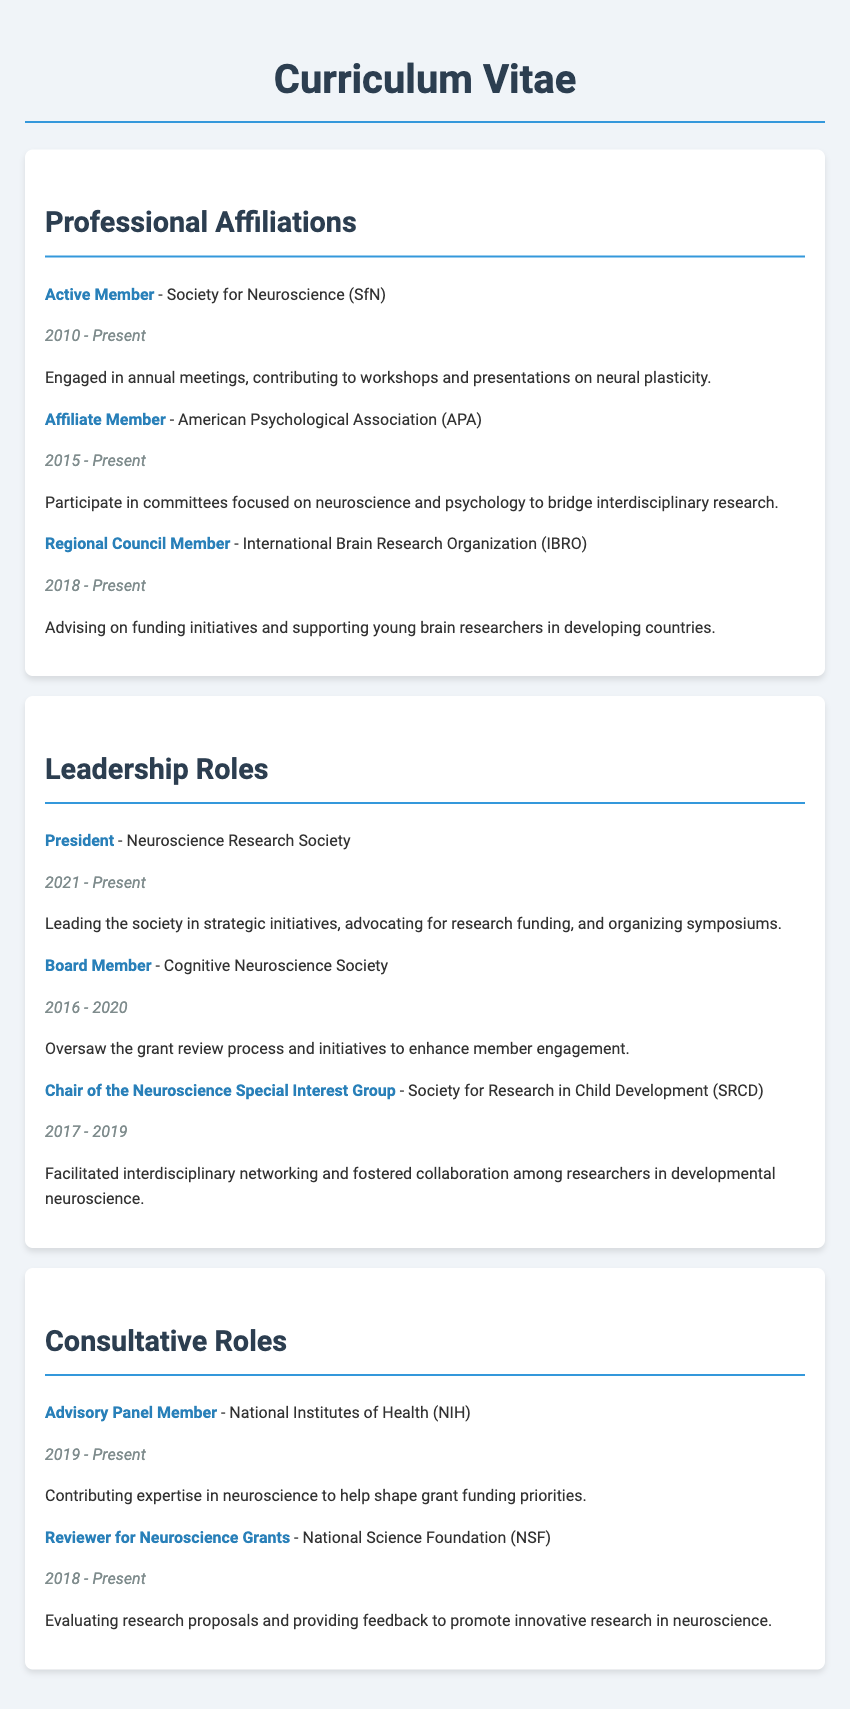what is the title of the curriculum vitae? The title appears at the top of the document as "Curriculum Vitae".
Answer: Curriculum Vitae how many years has the person been an Active Member of the Society for Neuroscience? The document states the membership period is from 2010 to Present, which is approximately 13 years.
Answer: 13 years who is currently the President of the Neuroscience Research Society? The document lists the title and organization along with the person's role, indicating they are the current President.
Answer: President which organization has the individual served as a Board Member? The document specifies the role of Board Member for the Cognitive Neuroscience Society.
Answer: Cognitive Neuroscience Society in which year did the individual start their role as Chair of the Neuroscience Special Interest Group? The document shows the person's term started in 2017.
Answer: 2017 what is the primary responsibility of the Regional Council Member at IBRO? The description states they are advising on funding initiatives and supporting young brain researchers.
Answer: Advising on funding initiatives how long did the individual serve as a Board Member from 2016 to 2020? The service duration is calculated from the years given in the document.
Answer: 4 years which professional society is focused on interdisciplinary research between neuroscience and psychology? The document indicates the individual is an Affiliate Member of the American Psychological Association.
Answer: American Psychological Association what is the primary role of the Advisory Panel Member at NIH? The role involves contributing expertise in neuroscience to help shape grant funding priorities.
Answer: Contributing expertise in neuroscience 